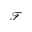Convert formula to latex. <formula><loc_0><loc_0><loc_500><loc_500>\mathcal { F }</formula> 